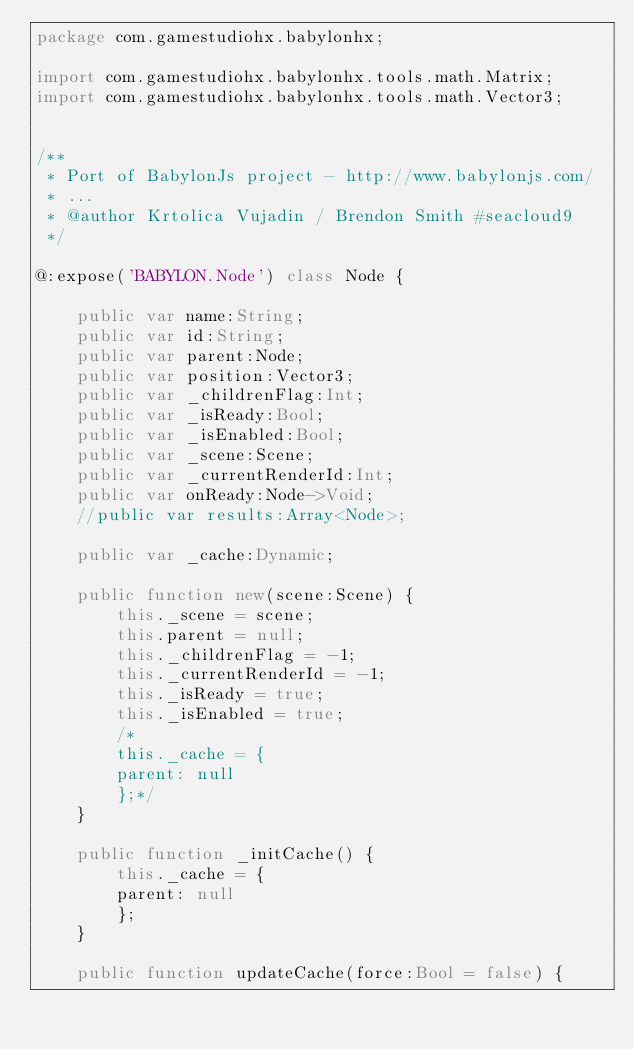<code> <loc_0><loc_0><loc_500><loc_500><_Haxe_>package com.gamestudiohx.babylonhx;

import com.gamestudiohx.babylonhx.tools.math.Matrix;
import com.gamestudiohx.babylonhx.tools.math.Vector3;


/**
 * Port of BabylonJs project - http://www.babylonjs.com/
 * ...
 * @author Krtolica Vujadin / Brendon Smith #seacloud9
 */

@:expose('BABYLON.Node') class Node {

    public var name:String;
    public var id:String;
    public var parent:Node;
    public var position:Vector3;
    public var _childrenFlag:Int;
    public var _isReady:Bool;
    public var _isEnabled:Bool;
    public var _scene:Scene;
    public var _currentRenderId:Int;
    public var onReady:Node->Void;
    //public var results:Array<Node>;

    public var _cache:Dynamic;

    public function new(scene:Scene) {
        this._scene = scene;
        this.parent = null;
        this._childrenFlag = -1;
        this._currentRenderId = -1;
        this._isReady = true;
        this._isEnabled = true;
        /*
        this._cache = {
        parent: null
        };*/
    }

    public function _initCache() {
        this._cache = {
        parent: null
        };
    }

    public function updateCache(force:Bool = false) {</code> 